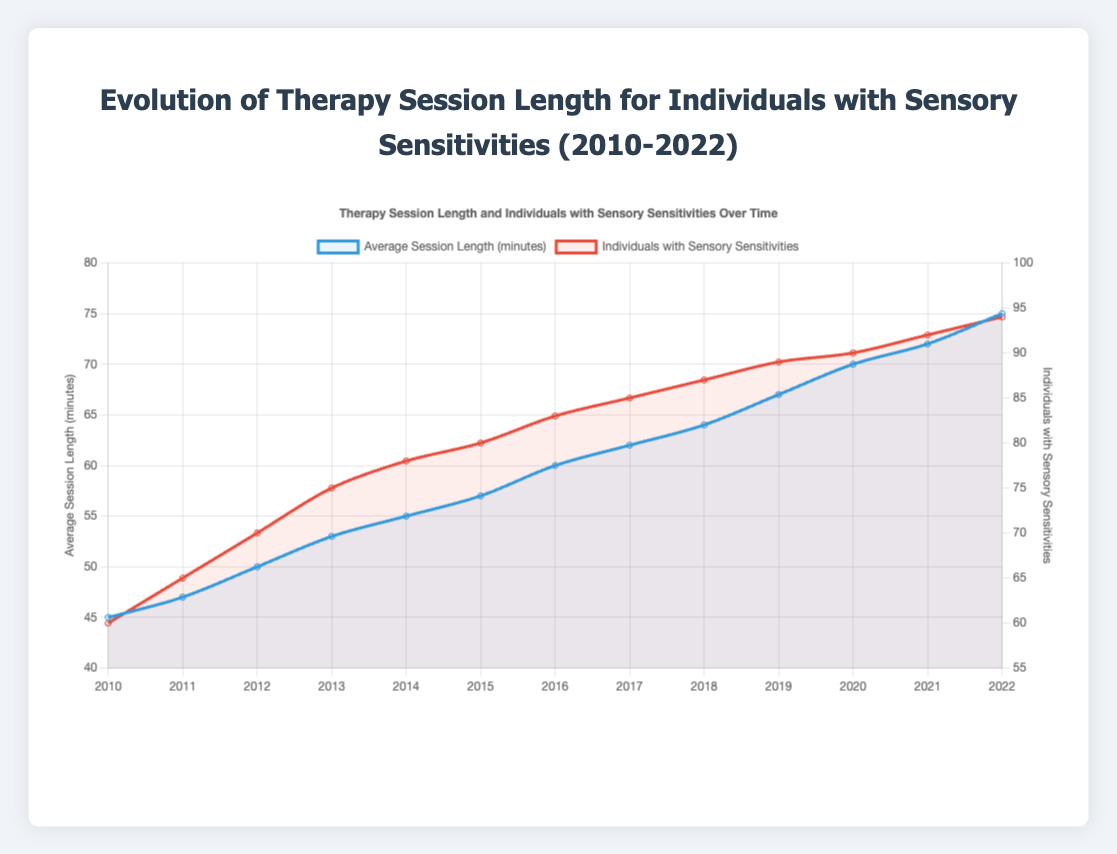What's the average session length for the years 2010 and 2022? To find the average session length for two years, we add the session lengths of those years and divide by 2. In 2010, the average session length was 45 minutes, and in 2022, it was 75 minutes. So, (45 + 75) / 2 = 60.
Answer: 60 Which year had the highest number of individuals with sensory sensitivities? We look for the year with the highest data point in the "Individuals with Sensory Sensitivities" line. The highest number is 94 in 2022.
Answer: 2022 By how many minutes did the average session length increase from 2010 to 2022? Subtract the session length in 2010 from the session length in 2022. In 2010, it was 45 minutes and in 2022, it was 75 minutes. So, 75 - 45 = 30.
Answer: 30 Which dataset has a steeper slope between 2018 and 2020, average session length or individuals with sensory sensitivities? To determine the steeper slope, we calculate the difference in values over the time period and compare. For session length: 70 - 64 = 6 minutes. For individuals with sensory sensitivities: 90 - 87 = 3 individuals. The slope of the average session length is steeper.
Answer: Average session length What is the difference between the number of individuals with sensory sensitivities and the average session length in minutes in 2014? To find the difference, subtract the average session length from the number of individuals with sensory sensitivities for that year. In 2014, the session length was 55 minutes and individuals were 78. So, 78 - 55 = 23.
Answer: 23 What is the average number of individuals with sensory sensitivities between 2010 and 2015? Sum the number of individuals between 2010 and 2015 and divide by the number of years (6). (60 + 65 + 70 + 75 + 78 + 80) / 6 = (428) / 6 ≈ 71.33.
Answer: 71.33 Which year shows the smallest increase in individuals with sensory sensitivities compared to the previous year? To find the smallest increase, compare the year-over-year increases. The smallest increase is between 2019 (89) and 2020 (90), which is 1 individual.
Answer: 2020 How does the trend of average session length compare to the trend of individuals with sensory sensitivities? Both trends are upward, indicating that over time both the average session length and the number of individuals with sensory sensitivities have increased.
Answer: Both increase 